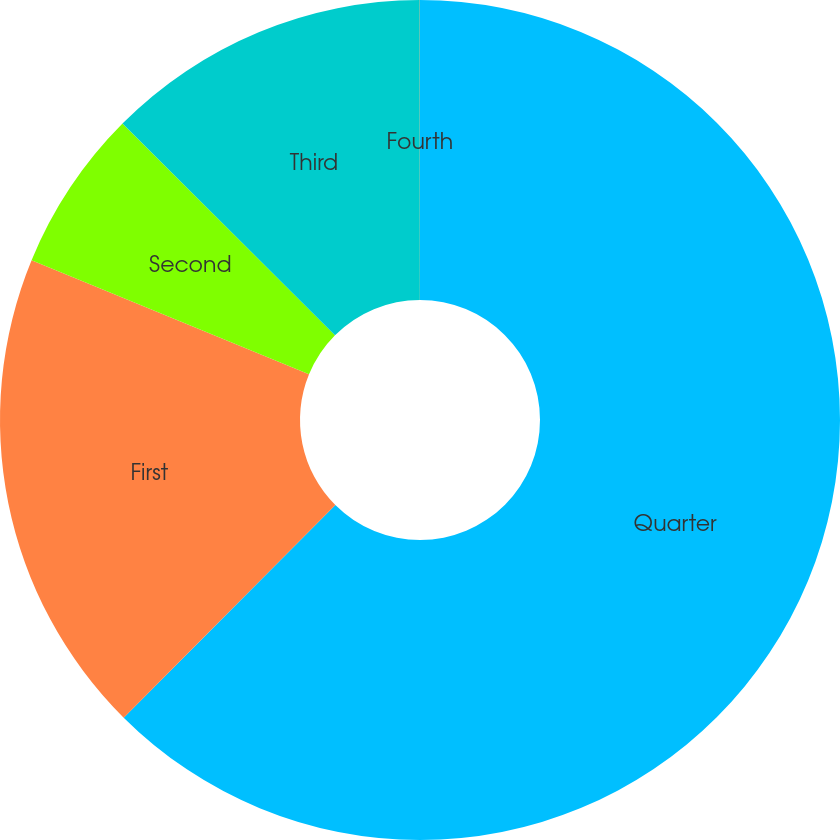Convert chart to OTSL. <chart><loc_0><loc_0><loc_500><loc_500><pie_chart><fcel>Quarter<fcel>First<fcel>Second<fcel>Third<fcel>Fourth<nl><fcel>62.47%<fcel>18.75%<fcel>6.26%<fcel>12.51%<fcel>0.02%<nl></chart> 